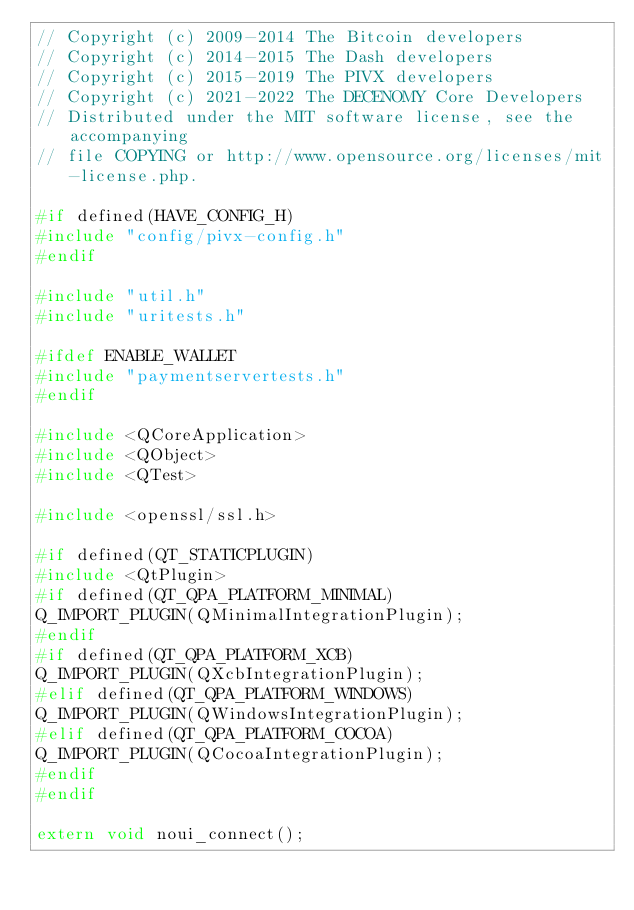<code> <loc_0><loc_0><loc_500><loc_500><_C++_>// Copyright (c) 2009-2014 The Bitcoin developers
// Copyright (c) 2014-2015 The Dash developers
// Copyright (c) 2015-2019 The PIVX developers
// Copyright (c) 2021-2022 The DECENOMY Core Developers
// Distributed under the MIT software license, see the accompanying
// file COPYING or http://www.opensource.org/licenses/mit-license.php.

#if defined(HAVE_CONFIG_H)
#include "config/pivx-config.h"
#endif

#include "util.h"
#include "uritests.h"

#ifdef ENABLE_WALLET
#include "paymentservertests.h"
#endif

#include <QCoreApplication>
#include <QObject>
#include <QTest>

#include <openssl/ssl.h>

#if defined(QT_STATICPLUGIN)
#include <QtPlugin>
#if defined(QT_QPA_PLATFORM_MINIMAL)
Q_IMPORT_PLUGIN(QMinimalIntegrationPlugin);
#endif
#if defined(QT_QPA_PLATFORM_XCB)
Q_IMPORT_PLUGIN(QXcbIntegrationPlugin);
#elif defined(QT_QPA_PLATFORM_WINDOWS)
Q_IMPORT_PLUGIN(QWindowsIntegrationPlugin);
#elif defined(QT_QPA_PLATFORM_COCOA)
Q_IMPORT_PLUGIN(QCocoaIntegrationPlugin);
#endif
#endif

extern void noui_connect();
</code> 